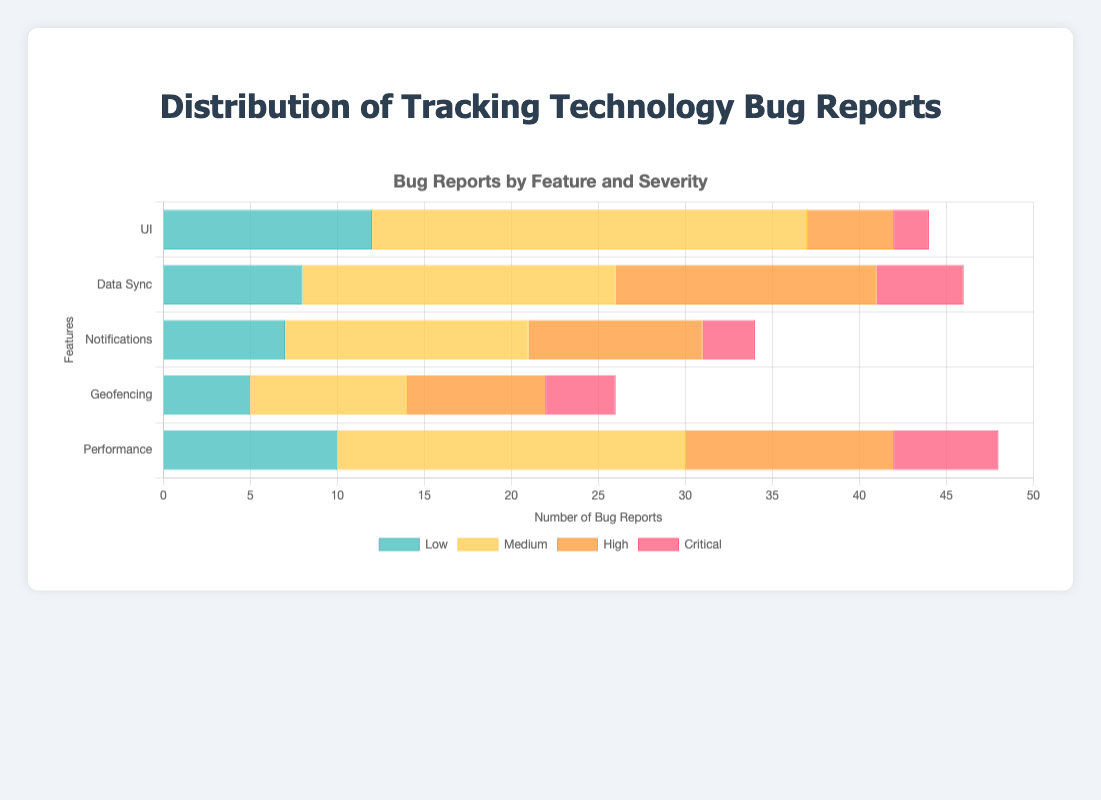Which feature has the highest number of critical bug reports? By observing the length of the segments representing "Critical" severity, we see that Performance has the longest bar indicating the highest number.
Answer: Performance Which feature has the least number of low severity bug reports? By comparing the lengths of the "Low" severity bars, Geofencing has the shortest bar.
Answer: Geofencing How many total bug reports are there for the UI feature? Sum the bug reports across all severities for UI: 12 (Low) + 25 (Medium) + 5 (High) + 2 (Critical) = 44.
Answer: 44 Which feature has the highest combined number of high and medium severity bug reports? Calculate the combined values for each feature and compare:
UI: 25 (Medium) + 5 (High) = 30,
Data Sync: 18 (Medium) + 15 (High) = 33,
Notifications: 14 (Medium) + 10 (High) = 24,
Geofencing: 9 (Medium) + 8 (High) = 17,
Performance: 20 (Medium) + 12 (High) = 32. 
Data Sync has the highest with 33.
Answer: Data Sync How does the number of medium severity bug reports for Notifications compare to the number for Geofencing? Compare the lengths of the "Medium" severity bars for Notifications (14) and Geofencing (9). Notifications has a higher number.
Answer: Notifications Which severity level has the most bug reports over all features combined? Sum the values for each severity level across all features and compare:
Low: 12+8+7+5+10 = 42,
Medium: 25+18+14+9+20 = 86,
High: 5+15+10+8+12 = 50,
Critical: 2+5+3+4+6 = 20.
Medium has the highest with 86.
Answer: Medium What is the total number of high and critical bug reports across all features? Sum the values for high and critical reports across all features: 
High: 5+15+10+8+12 = 50,
Critical: 2+5+3+4+6 = 20.
Total is 50 + 20 = 70.
Answer: 70 Which two features have the closest total number of bug reports? Calculate the total for each feature and compare:
UI: 12+25+5+2 = 44,
Data Sync: 8+18+15+5 = 46,
Notifications: 7+14+10+3 = 34,
Geofencing: 5+9+8+4 = 26,
Performance: 10+20+12+6 = 48.
The closest totals are UI (44) and Data Sync (46).
Answer: UI and Data Sync 